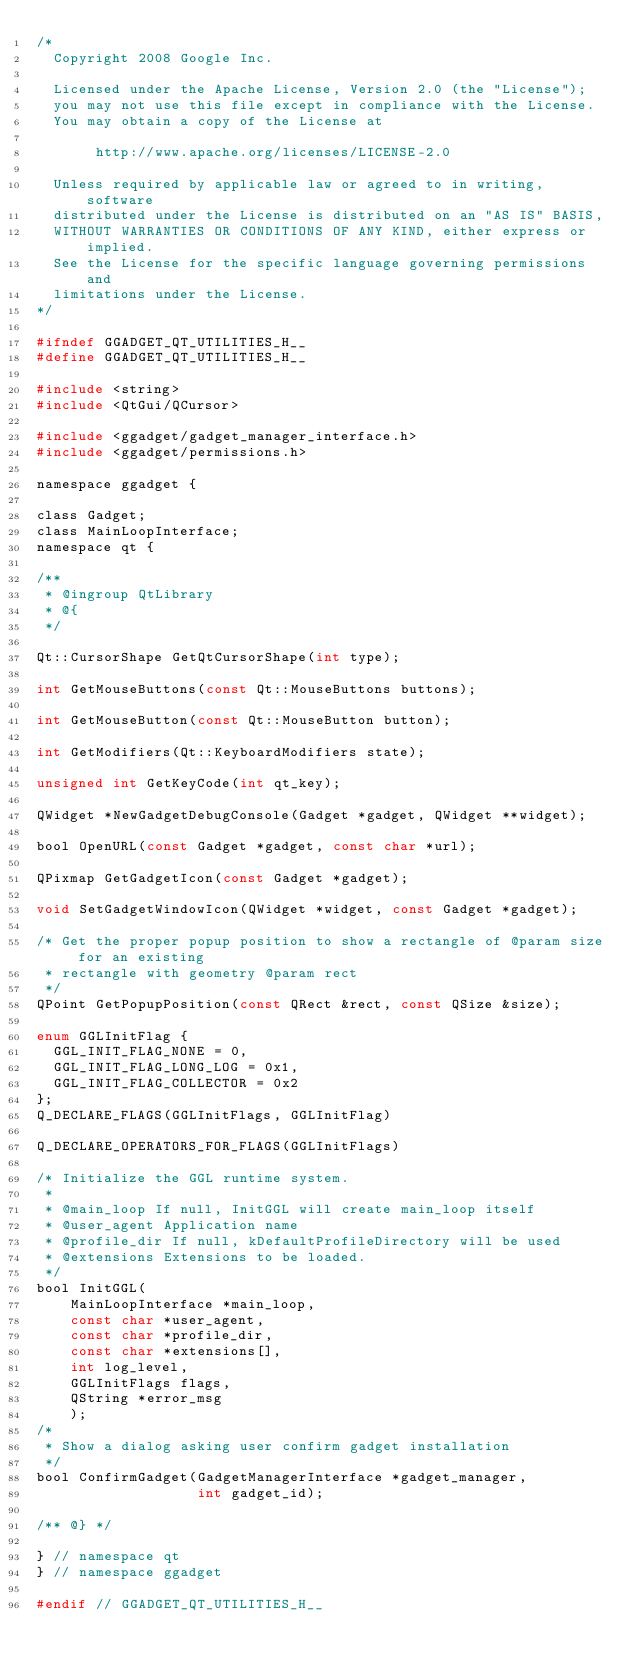Convert code to text. <code><loc_0><loc_0><loc_500><loc_500><_C_>/*
  Copyright 2008 Google Inc.

  Licensed under the Apache License, Version 2.0 (the "License");
  you may not use this file except in compliance with the License.
  You may obtain a copy of the License at

       http://www.apache.org/licenses/LICENSE-2.0

  Unless required by applicable law or agreed to in writing, software
  distributed under the License is distributed on an "AS IS" BASIS,
  WITHOUT WARRANTIES OR CONDITIONS OF ANY KIND, either express or implied.
  See the License for the specific language governing permissions and
  limitations under the License.
*/

#ifndef GGADGET_QT_UTILITIES_H__
#define GGADGET_QT_UTILITIES_H__

#include <string>
#include <QtGui/QCursor>

#include <ggadget/gadget_manager_interface.h>
#include <ggadget/permissions.h>

namespace ggadget {

class Gadget;
class MainLoopInterface;
namespace qt {

/**
 * @ingroup QtLibrary
 * @{
 */

Qt::CursorShape GetQtCursorShape(int type);

int GetMouseButtons(const Qt::MouseButtons buttons);

int GetMouseButton(const Qt::MouseButton button);

int GetModifiers(Qt::KeyboardModifiers state);

unsigned int GetKeyCode(int qt_key);

QWidget *NewGadgetDebugConsole(Gadget *gadget, QWidget **widget);

bool OpenURL(const Gadget *gadget, const char *url);

QPixmap GetGadgetIcon(const Gadget *gadget);

void SetGadgetWindowIcon(QWidget *widget, const Gadget *gadget);

/* Get the proper popup position to show a rectangle of @param size for an existing
 * rectangle with geometry @param rect
 */
QPoint GetPopupPosition(const QRect &rect, const QSize &size);

enum GGLInitFlag {
  GGL_INIT_FLAG_NONE = 0,
  GGL_INIT_FLAG_LONG_LOG = 0x1,
  GGL_INIT_FLAG_COLLECTOR = 0x2
};
Q_DECLARE_FLAGS(GGLInitFlags, GGLInitFlag)

Q_DECLARE_OPERATORS_FOR_FLAGS(GGLInitFlags)

/* Initialize the GGL runtime system.
 *
 * @main_loop If null, InitGGL will create main_loop itself
 * @user_agent Application name
 * @profile_dir If null, kDefaultProfileDirectory will be used
 * @extensions Extensions to be loaded.
 */
bool InitGGL(
    MainLoopInterface *main_loop,
    const char *user_agent,
    const char *profile_dir,
    const char *extensions[],
    int log_level,
    GGLInitFlags flags,
    QString *error_msg
    );
/*
 * Show a dialog asking user confirm gadget installation
 */
bool ConfirmGadget(GadgetManagerInterface *gadget_manager,
                   int gadget_id);

/** @} */

} // namespace qt
} // namespace ggadget

#endif // GGADGET_QT_UTILITIES_H__
</code> 